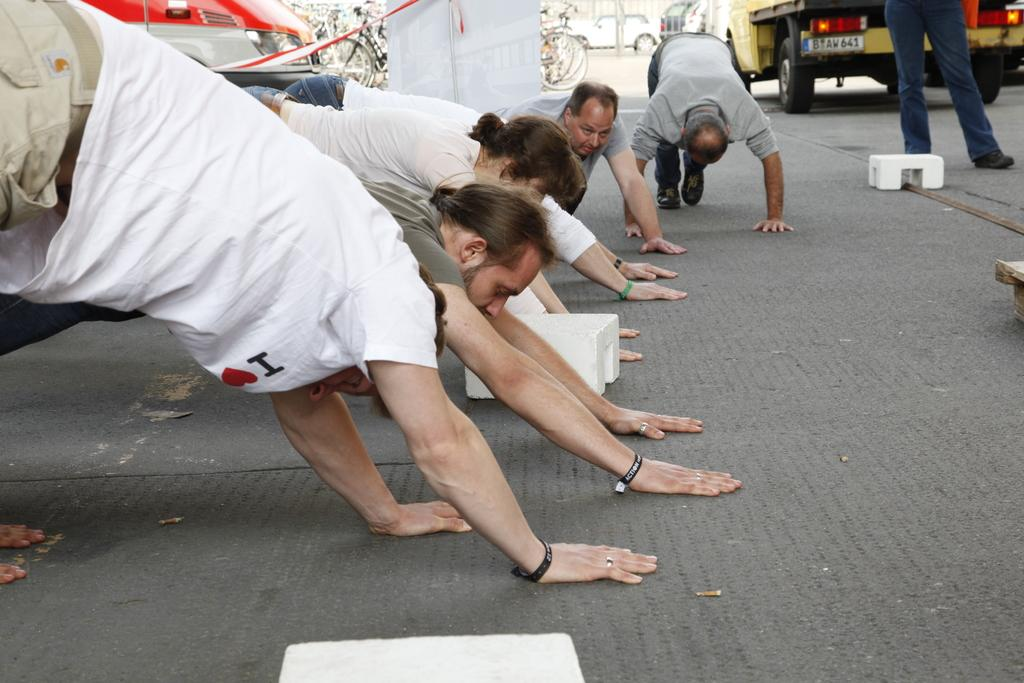What are the persons in the image doing with their hands and legs? The persons in the image have their hands and legs on the ground. What can be seen in the background of the image? There are other objects and vehicles in the background of the image. What type of desk can be seen in the image? There is no desk present in the image. How many eyes are visible on the persons in the image? The number of eyes cannot be determined from the image, as faces are not visible. 